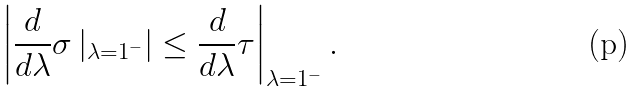Convert formula to latex. <formula><loc_0><loc_0><loc_500><loc_500>\left | \frac { d } { d \lambda } \sigma \left | _ { \lambda = 1 ^ { - } } \right | \leq \frac { d } { d \lambda } \tau \right | _ { \lambda = 1 ^ { - } } .</formula> 